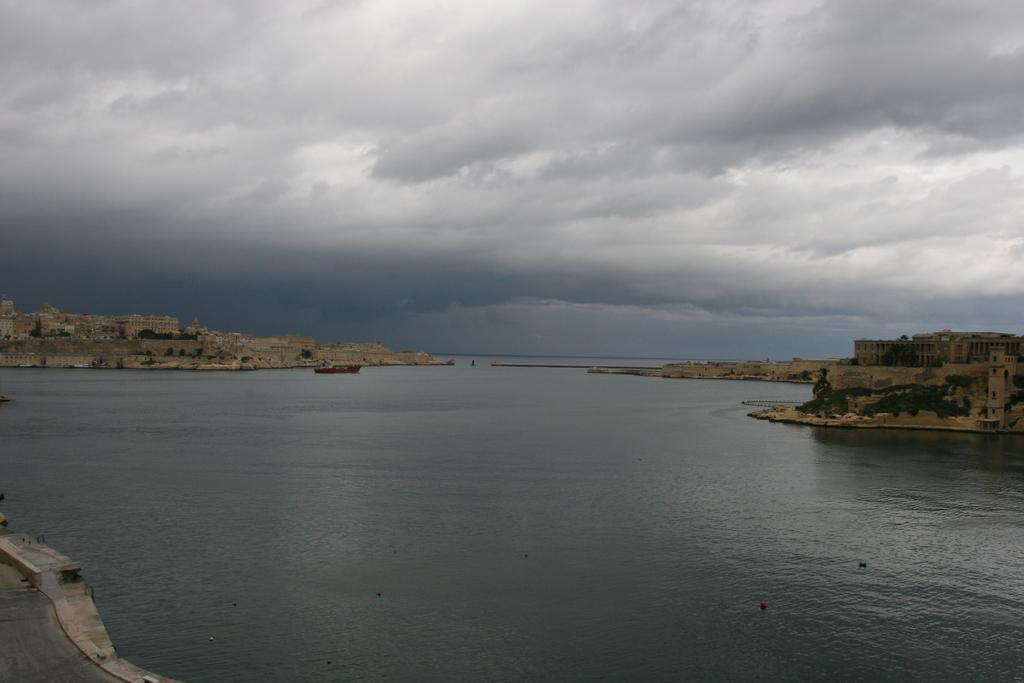What is the main feature of the image? There is water in the image. What is happening on the water? A boat is sailing on the water. What can be seen on the land in the image? There are buildings on both sides of the image. What is visible in the sky? Clouds are visible in the sky. Can you tell me how many hydrants are visible in the image? There are no hydrants present in the image. What type of snail can be seen crawling on the boat in the image? There are no snails visible in the image, let alone on the boat. 